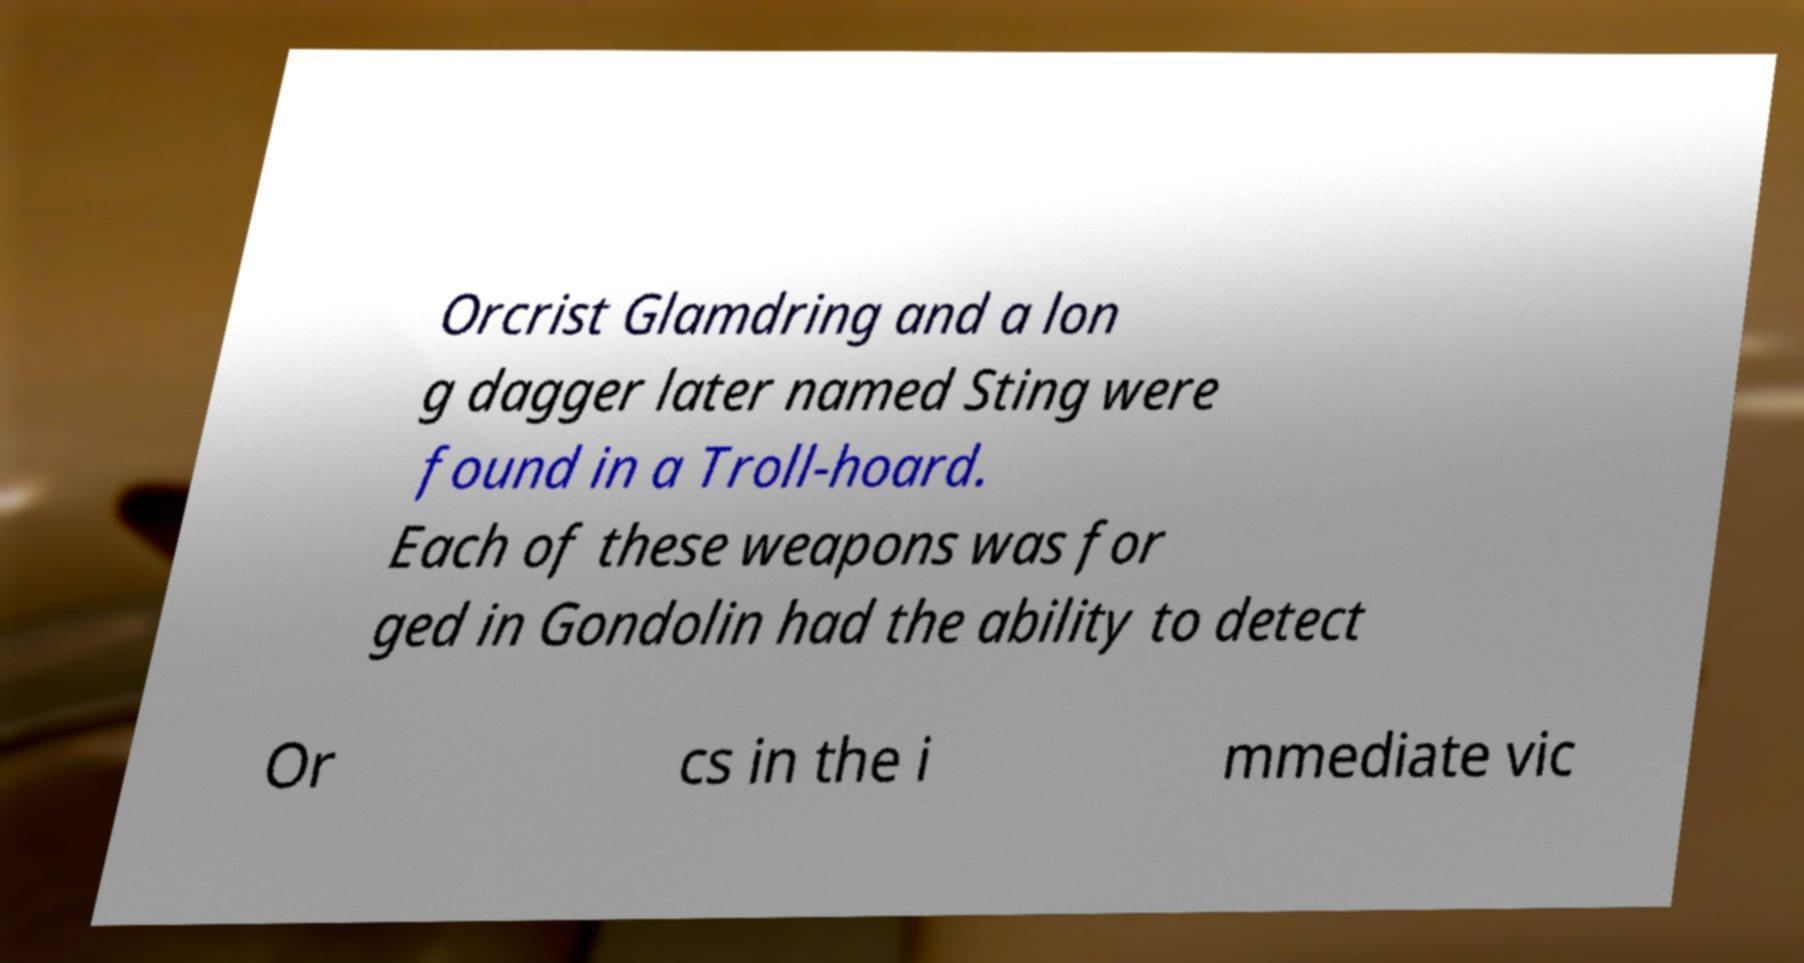Please read and relay the text visible in this image. What does it say? Orcrist Glamdring and a lon g dagger later named Sting were found in a Troll-hoard. Each of these weapons was for ged in Gondolin had the ability to detect Or cs in the i mmediate vic 